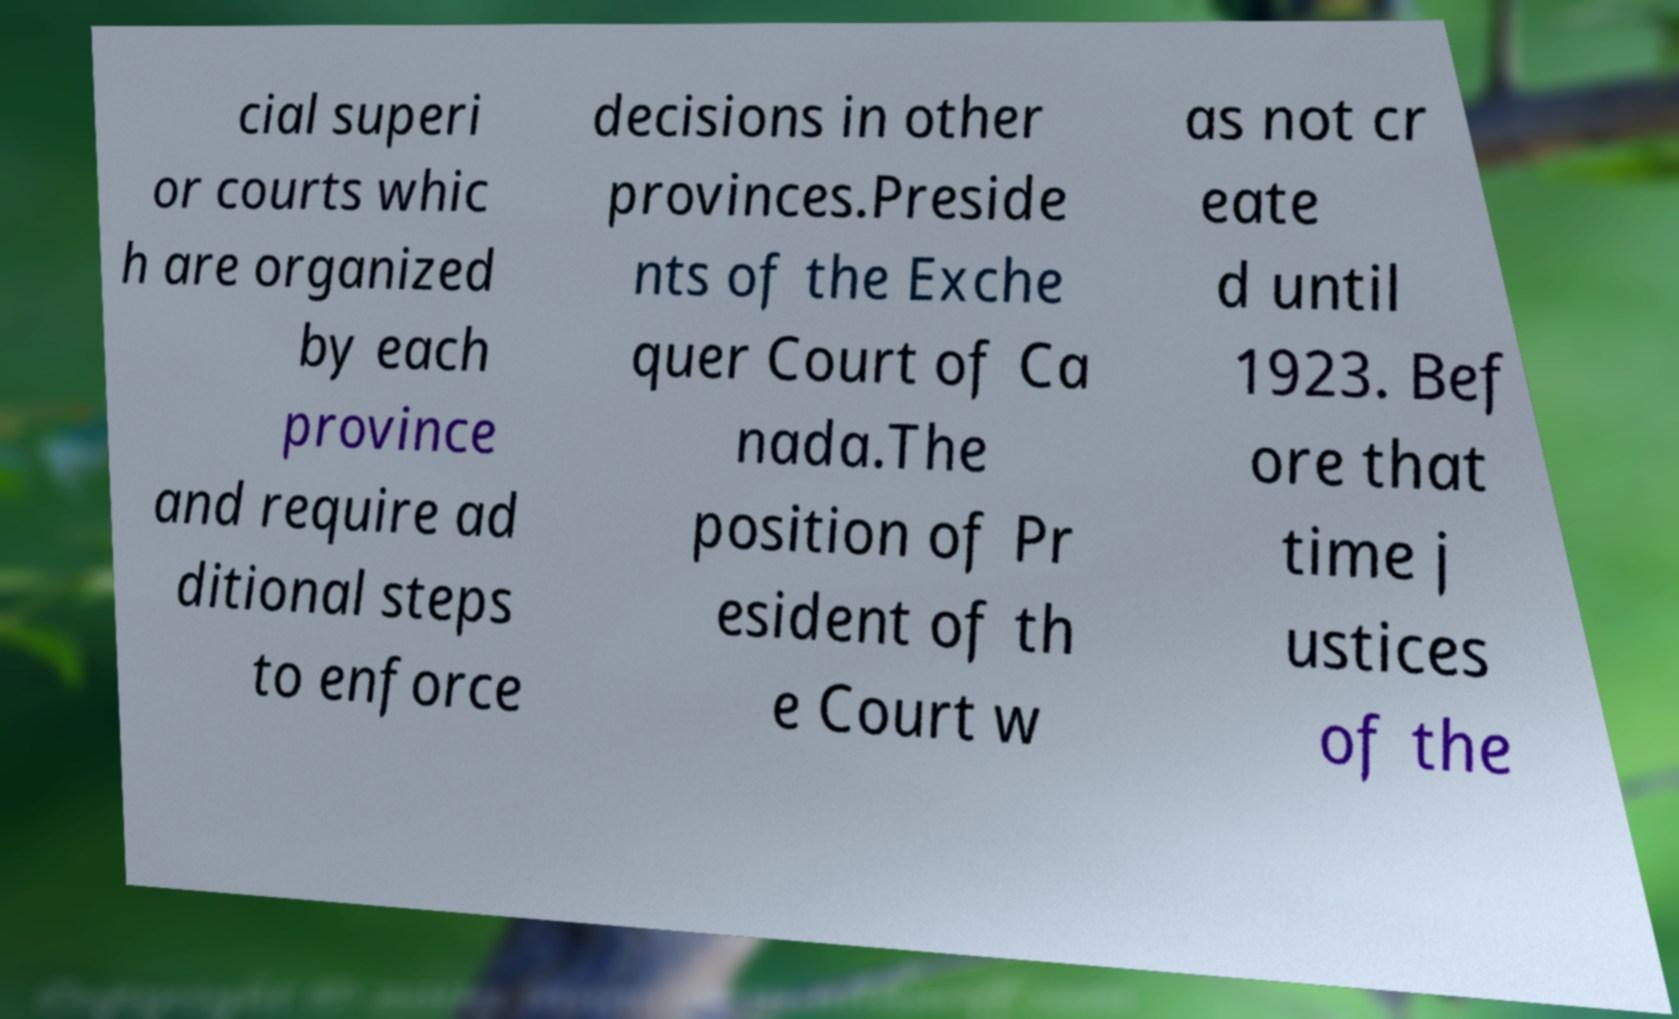Could you extract and type out the text from this image? cial superi or courts whic h are organized by each province and require ad ditional steps to enforce decisions in other provinces.Preside nts of the Exche quer Court of Ca nada.The position of Pr esident of th e Court w as not cr eate d until 1923. Bef ore that time j ustices of the 